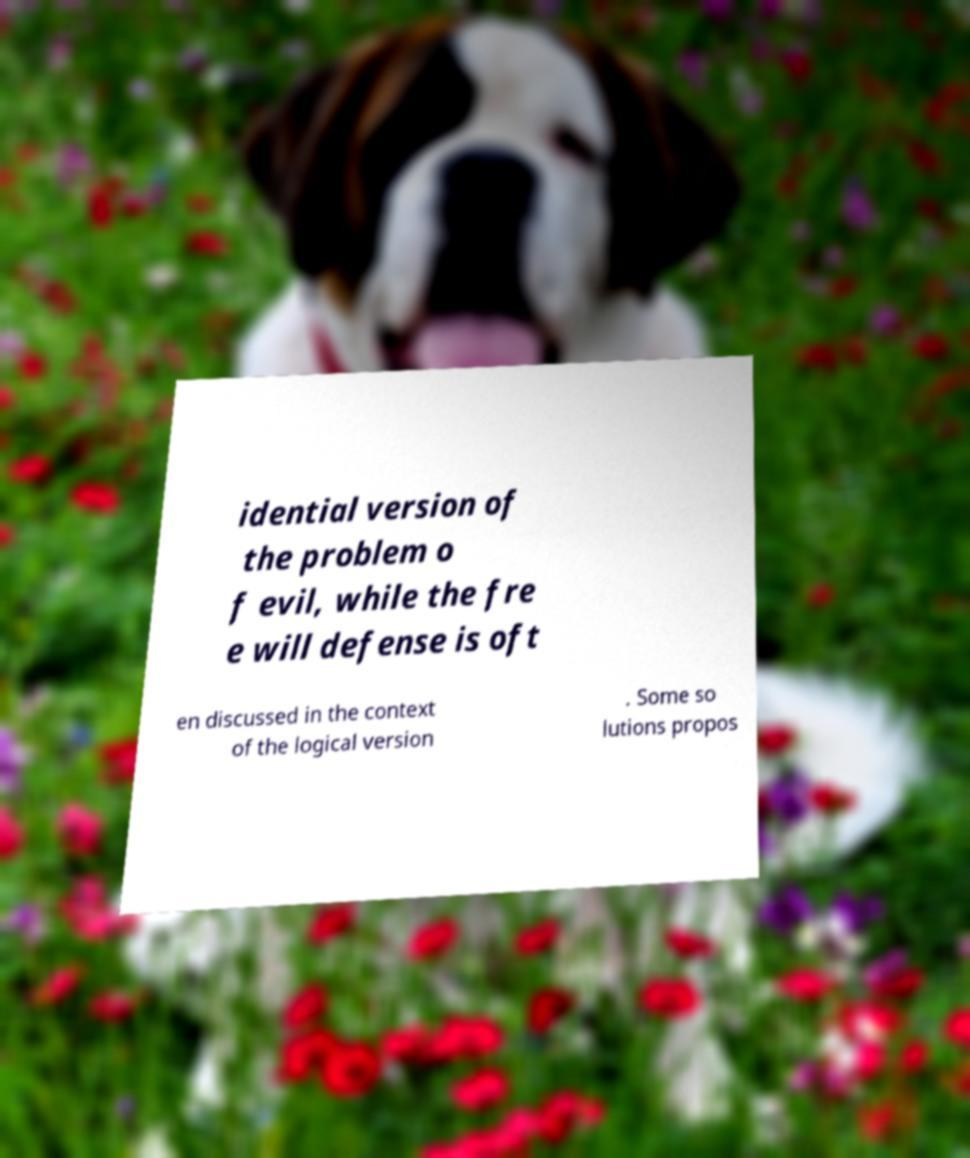There's text embedded in this image that I need extracted. Can you transcribe it verbatim? idential version of the problem o f evil, while the fre e will defense is oft en discussed in the context of the logical version . Some so lutions propos 